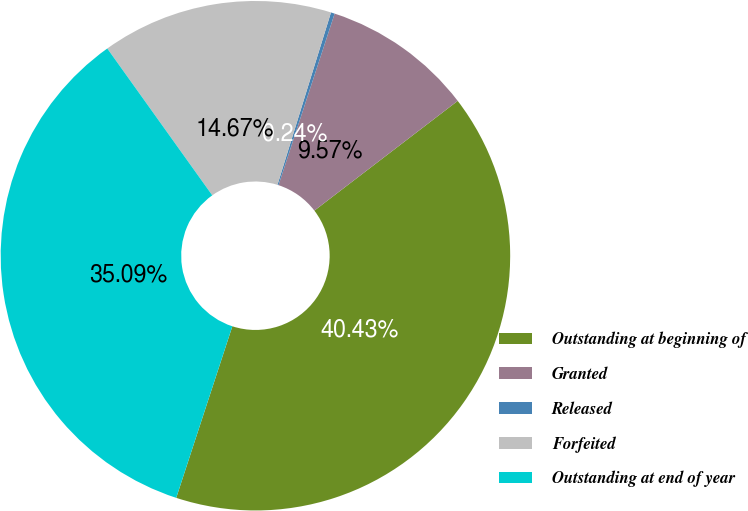Convert chart to OTSL. <chart><loc_0><loc_0><loc_500><loc_500><pie_chart><fcel>Outstanding at beginning of<fcel>Granted<fcel>Released<fcel>Forfeited<fcel>Outstanding at end of year<nl><fcel>40.43%<fcel>9.57%<fcel>0.24%<fcel>14.67%<fcel>35.09%<nl></chart> 